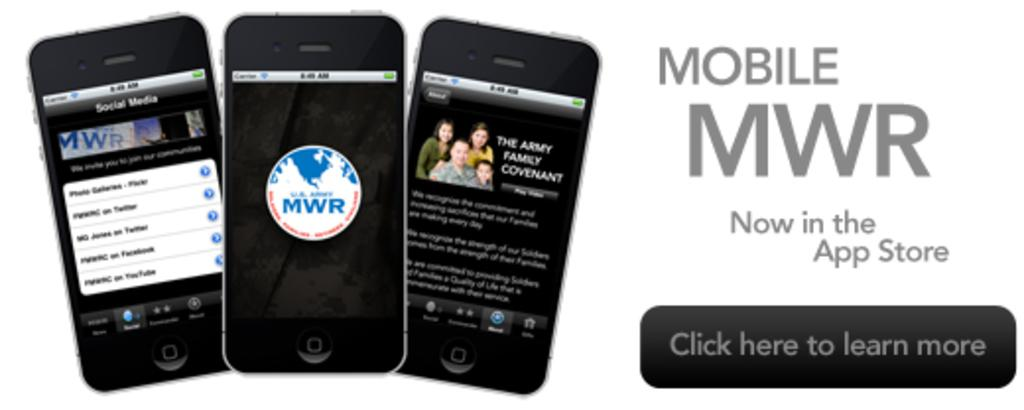What objects are present in the image? There are mobiles in the image. What else can be seen in the image besides the mobiles? There is text written on the image. What is the color of the background in the image? The background of the image is white. Can you see any ocean waves in the image? There is no ocean or waves present in the image; it features mobiles and text on a white background. 